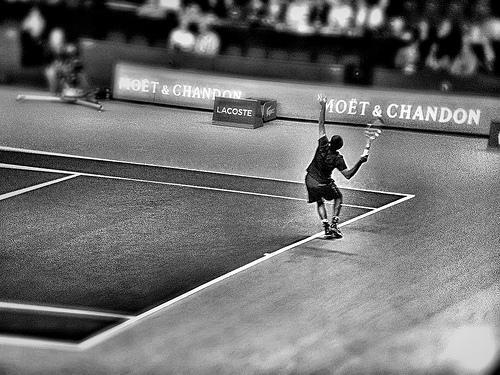How many people do you see in the picture?
Give a very brief answer. 1. 